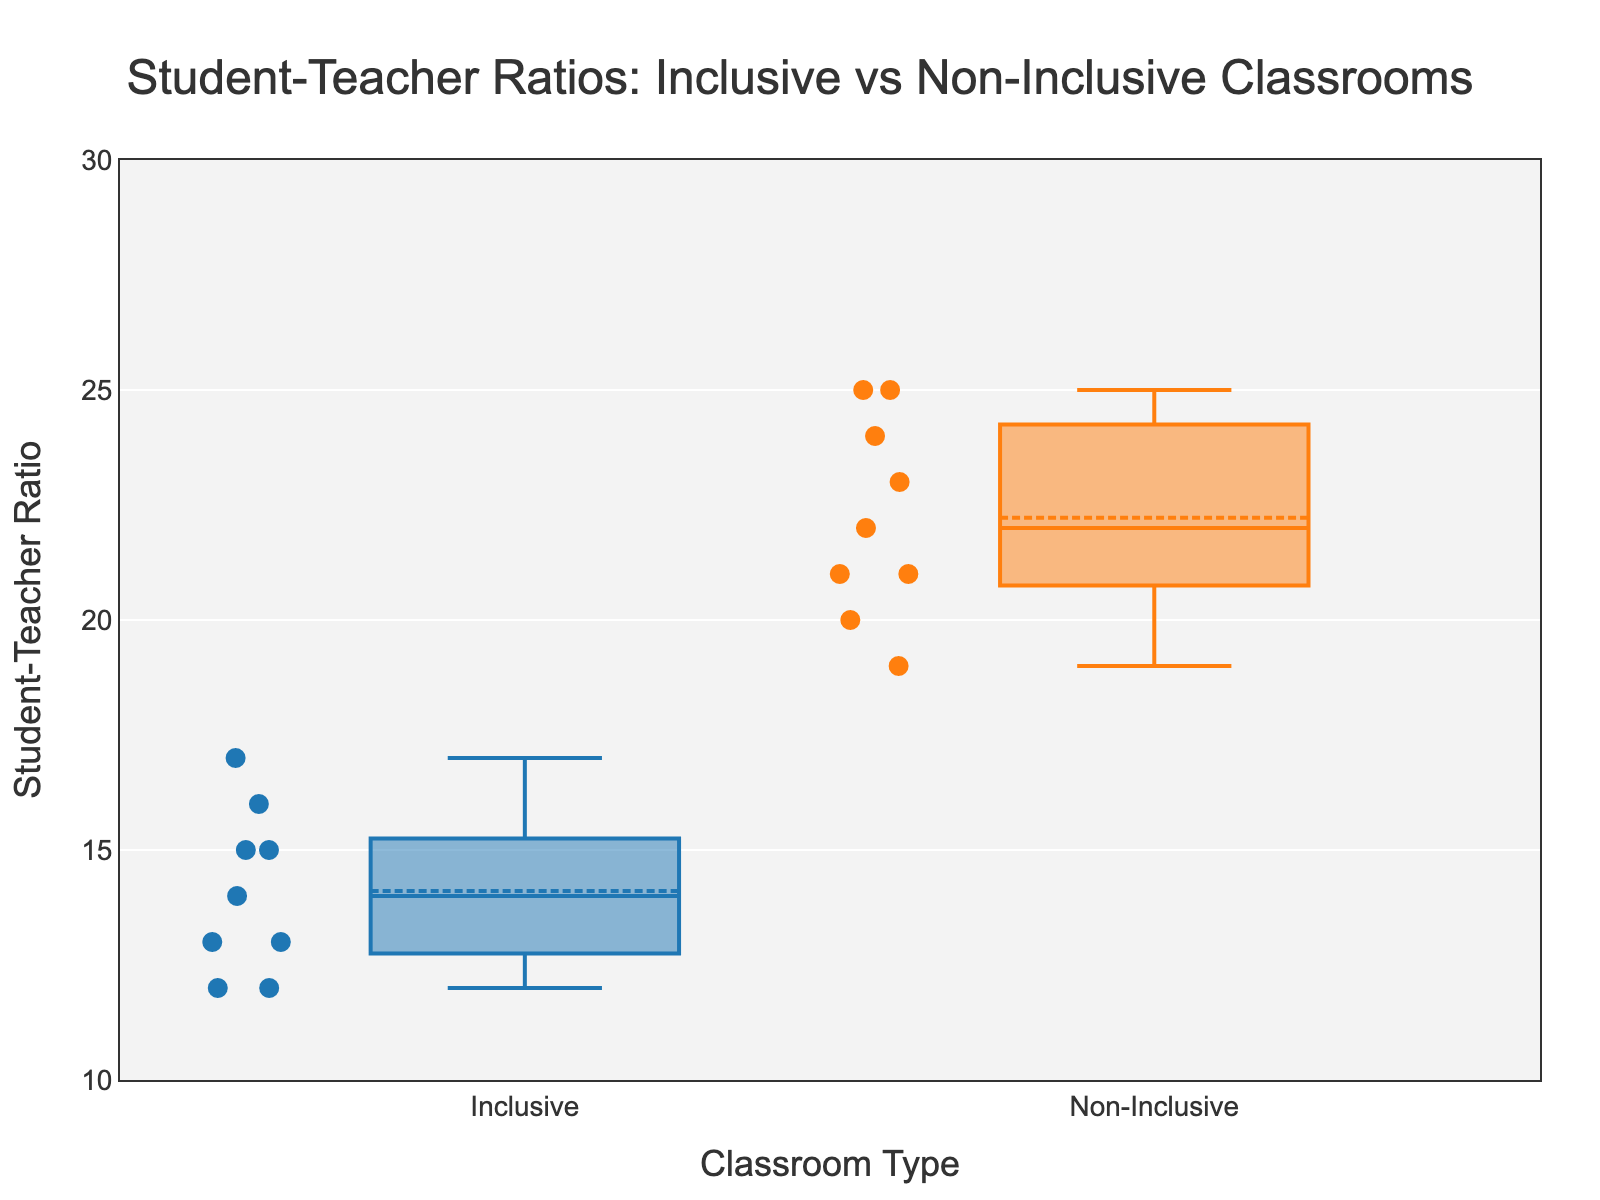What is the median student-teacher ratio in inclusive classrooms? The median for inclusive classrooms is the middle value when the ratios are listed in ascending order. The ratios are 12, 12, 13, 13, 14, 15, 15, 16, 17. The median is the fifth value, which is 14.
Answer: 14 What is the median student-teacher ratio in non-inclusive classrooms? The median for non-inclusive classrooms is the middle value when the ratios are listed in ascending order. The ratios are 19, 20, 21, 21, 22, 23, 24, 25, 25. The median is the fifth value, which is 22.
Answer: 22 How does the median student-teacher ratio compare between inclusive and non-inclusive classrooms? The median student-teacher ratio for inclusive classrooms is 14, while for non-inclusive classrooms it is 22. Therefore, the non-inclusive classrooms have a higher median ratio.
Answer: Non-inclusive classrooms have a higher median ratio What is the range of student-teacher ratios in inclusive classrooms? The range is the difference between the maximum and minimum values. In inclusive classrooms, the minimum ratio is 12 and the maximum is 17. So, the range is 17 - 12.
Answer: 5 What is the range of student-teacher ratios in non-inclusive classrooms? The range is the difference between the maximum and minimum values. In non-inclusive classrooms, the minimum ratio is 19 and the maximum is 25. So, the range is 25 - 19.
Answer: 6 What is the interquartile range (IQR) for the inclusive classrooms' ratios? The IQR is the difference between the third quartile (Q3) and the first quartile (Q1). For inclusive classrooms, Q1 (25th percentile) is 13 and Q3 (75th percentile) is 15. Therefore, the IQR is 15 - 13.
Answer: 2 What classroom type has the least variance in student-teacher ratios? By visually comparing the spread of the scatter points around the boxplot, we can see that the inclusive classrooms have less spread (narrower interquartile range), indicating less variance.
Answer: Inclusive classrooms Which data point represents the maximum student-teacher ratio in non-inclusive classrooms? In non-inclusive classrooms, the highest student-teacher ratio is at the maximum point of the box plot, which is 25.
Answer: 25 How many data points are there for inclusive classrooms? The scatter points above the inclusive box plot represent the number of data points. Counting them gives 9.
Answer: 9 Is the average student-teacher ratio higher in non-inclusive classrooms than in inclusive classrooms? The average is indicated by the mean line in the box plot. The mean line for non-inclusive classrooms is at a higher position on the y-axis compared to inclusive classrooms.
Answer: Yes 